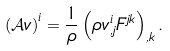<formula> <loc_0><loc_0><loc_500><loc_500>\left ( \mathcal { A } v \right ) ^ { i } = \frac { 1 } { \rho } \left ( \rho v ^ { i } _ { , j } F ^ { j k } \right ) _ { , k } .</formula> 